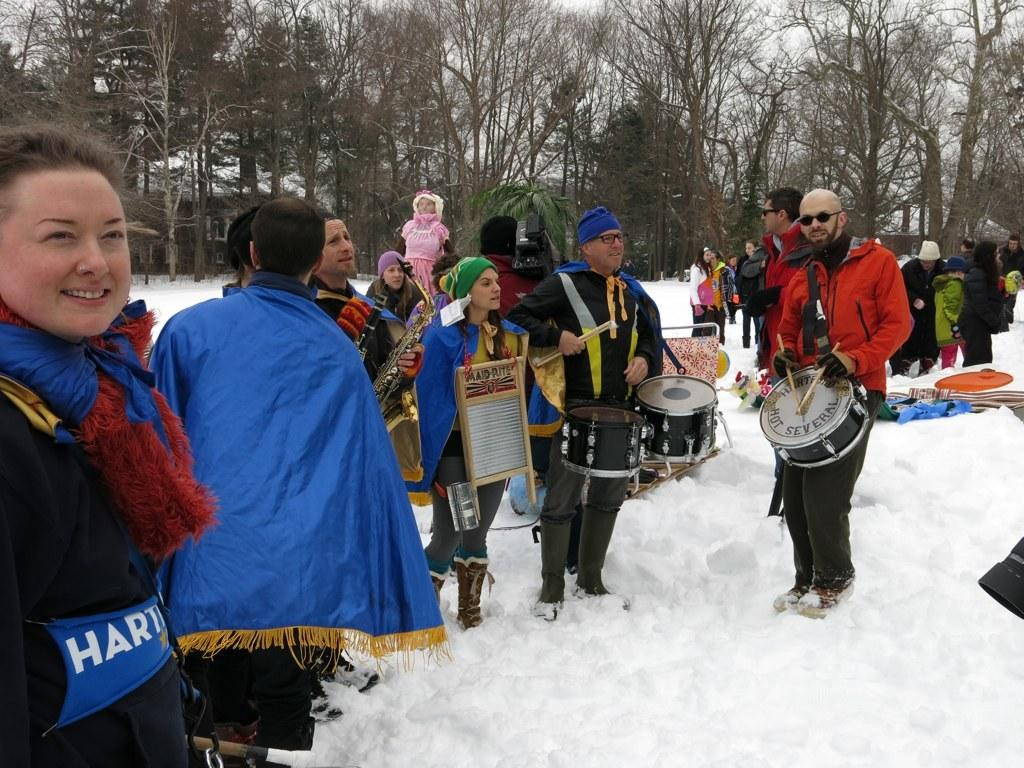Provide a one-sentence caption for the provided image. A man with a drum is part of a group of people in the snow that play for the Hartford Hot Several. 